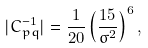<formula> <loc_0><loc_0><loc_500><loc_500>| C _ { p q } ^ { - 1 } | = \frac { 1 } { 2 0 } \left ( \frac { 1 5 } { \sigma ^ { 2 } } \right ) ^ { 6 } ,</formula> 